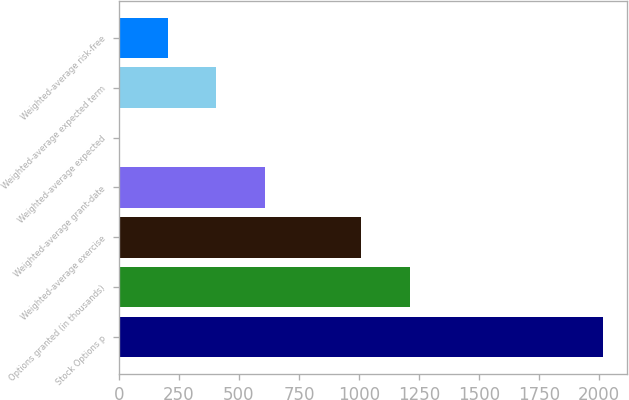<chart> <loc_0><loc_0><loc_500><loc_500><bar_chart><fcel>Stock Options p<fcel>Options granted (in thousands)<fcel>Weighted-average exercise<fcel>Weighted-average grant-date<fcel>Weighted-average expected<fcel>Weighted-average expected term<fcel>Weighted-average risk-free<nl><fcel>2018<fcel>1211.64<fcel>1010.05<fcel>606.87<fcel>2.1<fcel>405.28<fcel>203.69<nl></chart> 